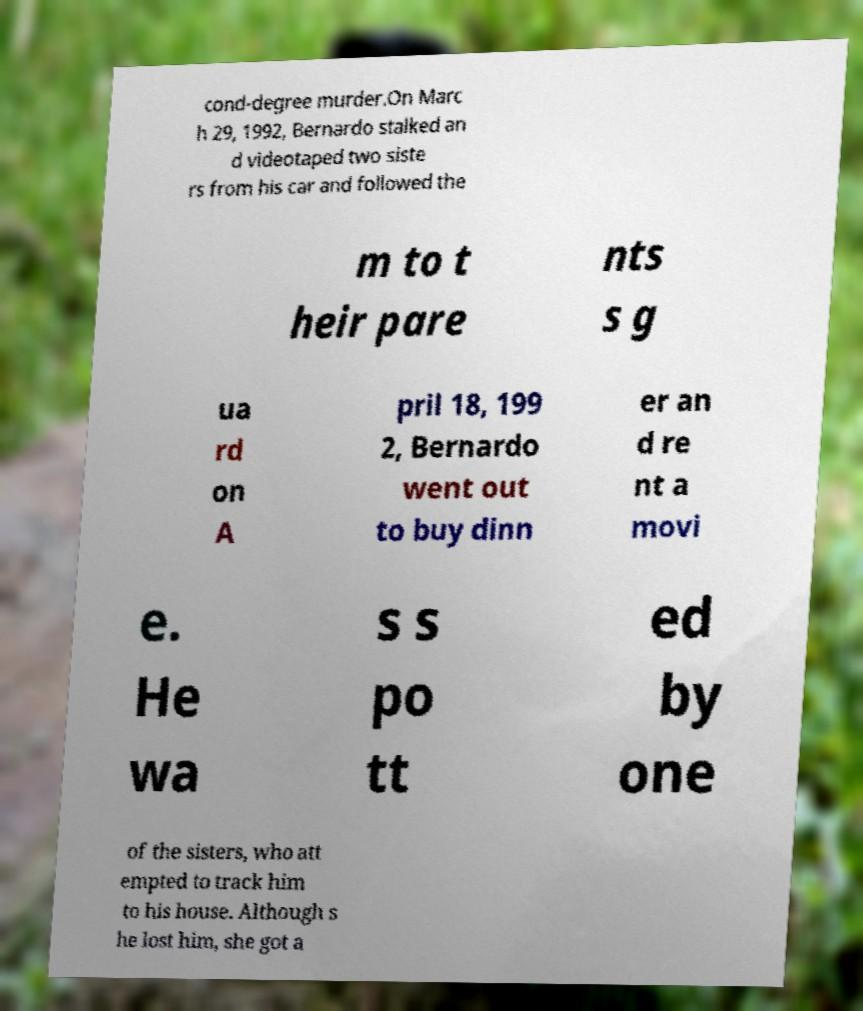Please read and relay the text visible in this image. What does it say? cond-degree murder.On Marc h 29, 1992, Bernardo stalked an d videotaped two siste rs from his car and followed the m to t heir pare nts s g ua rd on A pril 18, 199 2, Bernardo went out to buy dinn er an d re nt a movi e. He wa s s po tt ed by one of the sisters, who att empted to track him to his house. Although s he lost him, she got a 